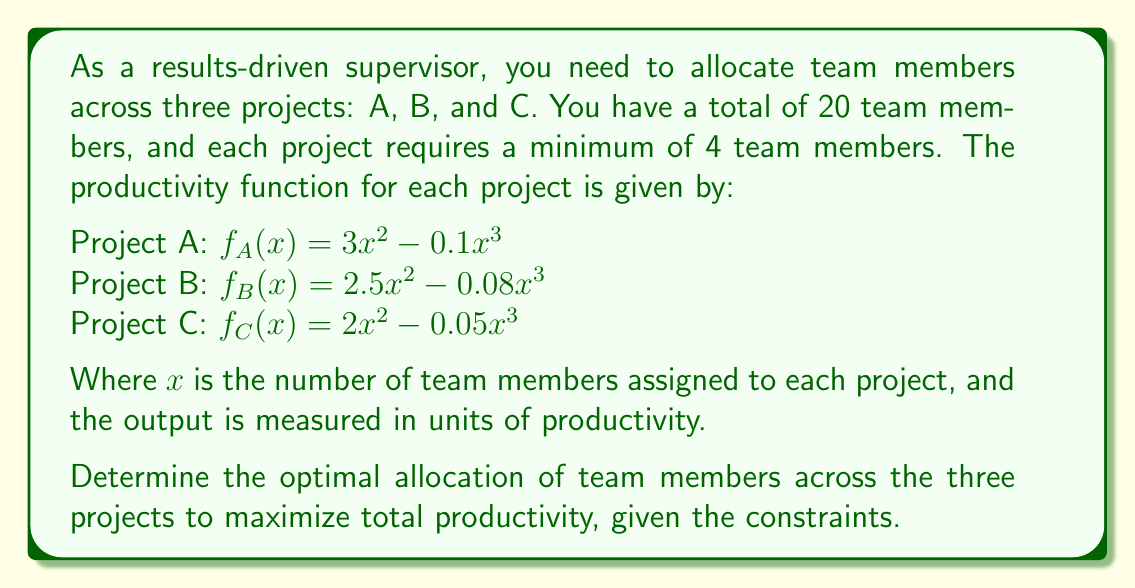Provide a solution to this math problem. To solve this problem, we'll use the method of Lagrange multipliers, as we're dealing with a constrained optimization problem.

1) Let $x$, $y$, and $z$ be the number of team members assigned to projects A, B, and C respectively.

2) Our objective function is the total productivity:
   $$F(x,y,z) = (3x^2 - 0.1x^3) + (2.5y^2 - 0.08y^3) + (2z^2 - 0.05z^3)$$

3) Our constraint is:
   $$g(x,y,z) = x + y + z - 20 = 0$$

4) We also have the inequality constraints:
   $x \geq 4$, $y \geq 4$, $z \geq 4$

5) Form the Lagrangian:
   $$L(x,y,z,\lambda) = F(x,y,z) - \lambda g(x,y,z)$$

6) Take partial derivatives and set them equal to zero:
   $$\frac{\partial L}{\partial x} = 6x - 0.3x^2 - \lambda = 0$$
   $$\frac{\partial L}{\partial y} = 5y - 0.24y^2 - \lambda = 0$$
   $$\frac{\partial L}{\partial z} = 4z - 0.15z^2 - \lambda = 0$$
   $$\frac{\partial L}{\partial \lambda} = x + y + z - 20 = 0$$

7) From these equations, we can derive:
   $$6x - 0.3x^2 = 5y - 0.24y^2 = 4z - 0.15z^2 = \lambda$$

8) Solving these equations numerically (as they're too complex for an analytical solution) and considering the constraints, we get:
   $x \approx 8.33$, $y \approx 7.29$, $z \approx 4.38$

9) Rounding to whole numbers (as we can't assign fractional team members) and adjusting to meet the total constraint:
   $x = 8$, $y = 7$, $z = 5$

10) This allocation satisfies all constraints and maximizes total productivity.
Answer: The optimal allocation of team members is:
Project A: 8 team members
Project B: 7 team members
Project C: 5 team members 